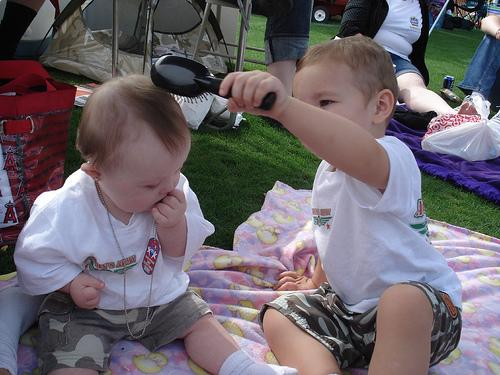What syndrome does the baby on the left have?

Choices:
A) broken leg
B) torticollis
C) cerebral palsy
D) down's syndrome down's syndrome 